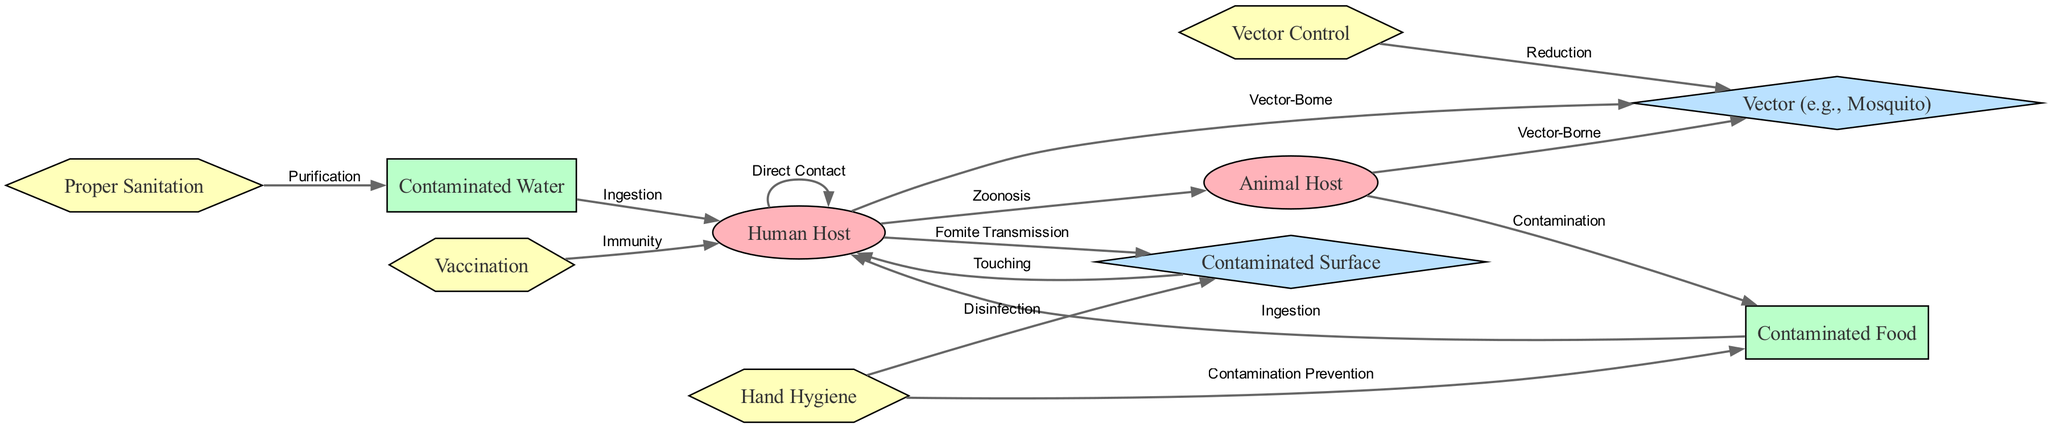What is the total number of nodes in the diagram? To find the total number of nodes, I count all the unique entities listed under the "nodes" section. There are ten entities: Human Host, Animal Host, Contaminated Food, Contaminated Water, Contaminated Surface, Vector (e.g., Mosquito), Hand Hygiene, Vaccination, Proper Sanitation, and Vector Control. Therefore, the total number of nodes is ten.
Answer: 10 What type of transmission occurs between human hosts? The edge connecting Human Host to itself is labeled "Direct Contact," indicating a form of transmission. Therefore, the type of transmission that occurs between human hosts is direct contact.
Answer: Direct Contact Which prevention measure is connected to Contaminated Food? I look at the edges to see which prevention measure connects to Contaminated Food. The edge labeled "Contamination Prevention" leads from Hand Hygiene to Contaminated Food. Thus, the prevention measure connected to Contaminated Food is Hand Hygiene.
Answer: Hand Hygiene How many types of hosts are identified in the diagram? In the nodes section, I find two categories regarding hosts: Human Host and Animal Host. Counting these, I see there are two types of hosts identified in the diagram.
Answer: 2 What is the purpose of vector control in the context of this diagram? Vector Control has a directed connection to Vector (e.g., Mosquito), with the label "Reduction." This indicates its purpose is to reduce vector populations, thereby mitigating their role in the transmission of diseases.
Answer: Reduction Which nodes are considered tertiary sources in the diagram? Tertiary sources are defined as those with the type "tertiary." I look at the nodes section and see Contaminated Surface and Vector (e.g., Mosquito) fall into this category. Hence, the tertiary sources in the diagram are Contaminated Surface and Vector (e.g., Mosquito).
Answer: Contaminated Surface, Vector (e.g., Mosquito) What is the relationship between contaminated water and human hosts? The edge between Contaminated Water and Human Host is labeled "Ingestion," indicating that human hosts can acquire pathogens through the ingestion of contaminated water. Thus, the relationship is based on ingestion.
Answer: Ingestion Which prevention measure directly interacts with Contaminated Water? I inspect the edges to see what prevention measure connects to Contaminated Water. The edge leading from Proper Sanitation to Contaminated Water is labeled "Purification." This implies that Proper Sanitation is the prevention measure that interacts with Contaminated Water.
Answer: Proper Sanitation What type of relationship do animal hosts have with vectors? There are edges identified that connect Animal Host to Vector (e.g., Mosquito). Both connections are labeled "Vector-Borne," indicating the relationship is through vector-borne transmission. Thus, animal hosts are associated with vectors through vector-borne transmission.
Answer: Vector-Borne 